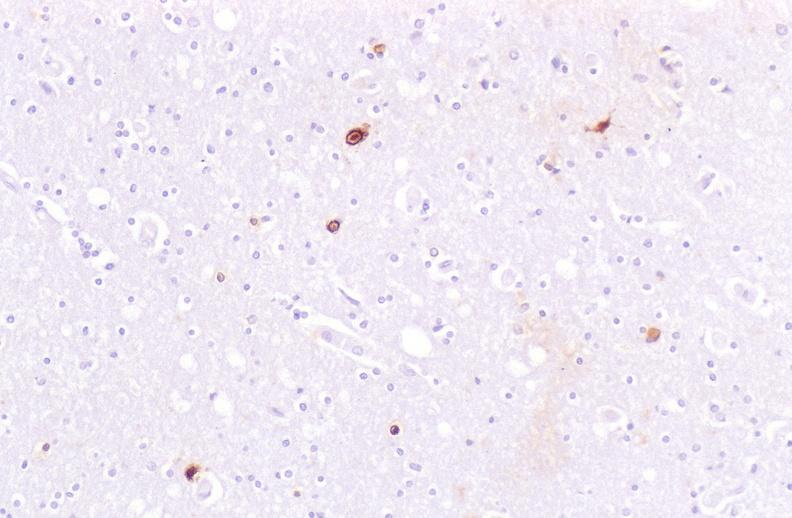does that show brain, herpes simplex virus immunohistochemistry?
Answer the question using a single word or phrase. No 